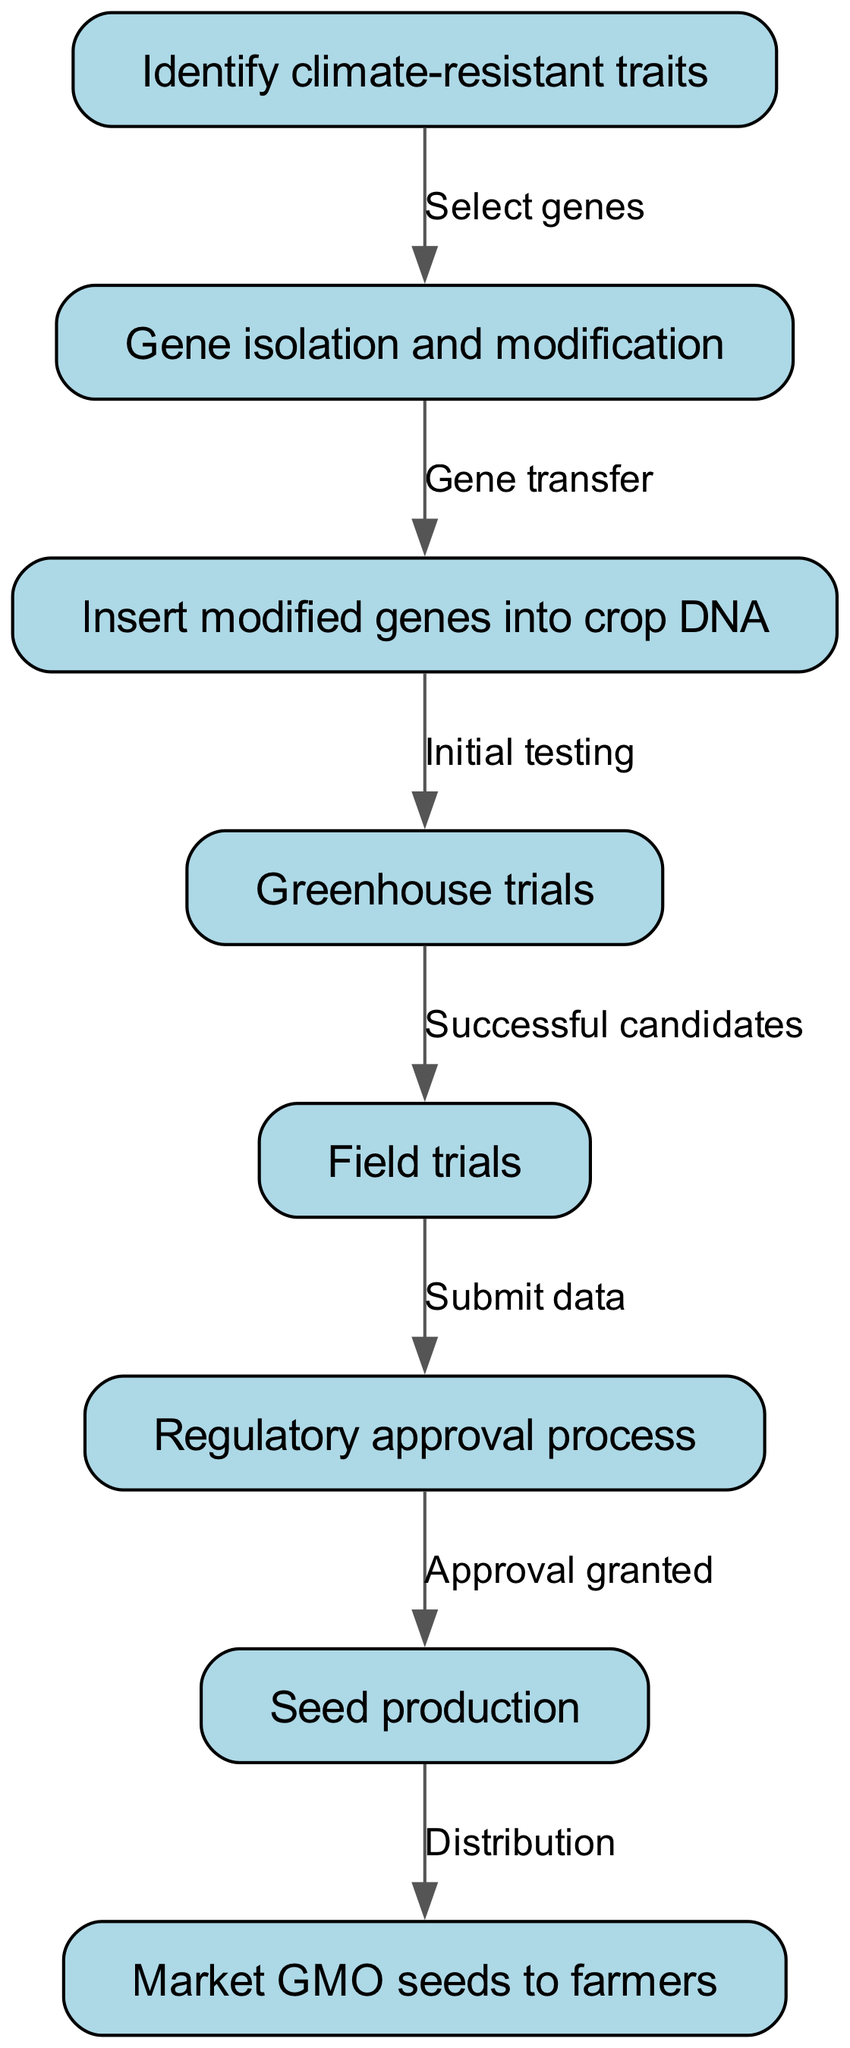What is the first step in the GMO seed development process? The first step in the process is identified in the diagram as "Identify climate-resistant traits," which is the initial node.
Answer: Identify climate-resistant traits How many nodes are present in the diagram? By counting the nodes mentioned, there are a total of eight distinct nodes that describe different steps in the GMO seed development process.
Answer: 8 What is the relationship between "Field trials" and "Regulatory approval process"? The relationship is represented by the edge that indicates that upon completing field trials successfully, data will be submitted to proceed to the regulatory approval process.
Answer: Submit data Which step comes after "Gene isolation and modification"? The diagram indicates that after the "Gene isolation and modification" step, the next step is the "Insert modified genes into crop DNA" step, connected by the edge labeled "Gene transfer."
Answer: Insert modified genes into crop DNA What stage follows "Greenhouse trials"? Upon successful candidates from greenhouse trials, the next stage is "Field trials," which is indicated by the edge labeled "Successful candidates."
Answer: Field trials Which node is the final step before marketing the GMO seeds? The final step before marketing is "Seed production," shown just prior to the last node in the diagram, which indicates the completion of development.
Answer: Seed production How many edges are in the diagram? Counting the connections or edges that show the flow from one step to the next, we find that there are a total of seven edges connecting the various steps in the process.
Answer: 7 What does the edge from "Regulatory approval process" to "Seed production" signify? This edge, labeled "Approval granted," signifies that once the regulatory approval process is complete, seed production can commence, indicating that it's a crucial step.
Answer: Approval granted What is the direct output of "Insert modified genes into crop DNA"? The direct output of this step is the initiation of "Greenhouse trials," which follows this process, as indicated in the diagram.
Answer: Greenhouse trials 